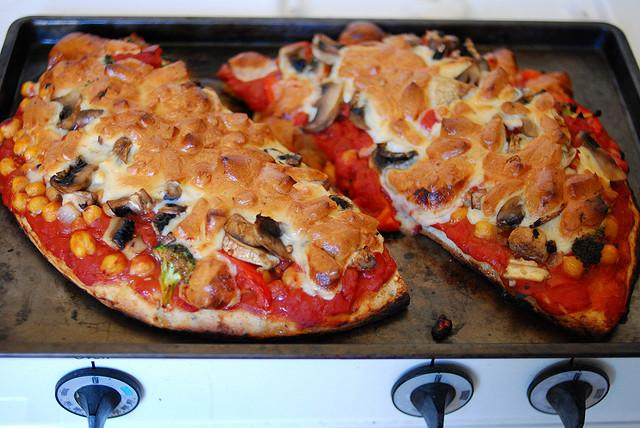What are the round things on the outer edge?

Choices:
A) garbanzo beans
B) peas
C) olives
D) cheese balls garbanzo beans 